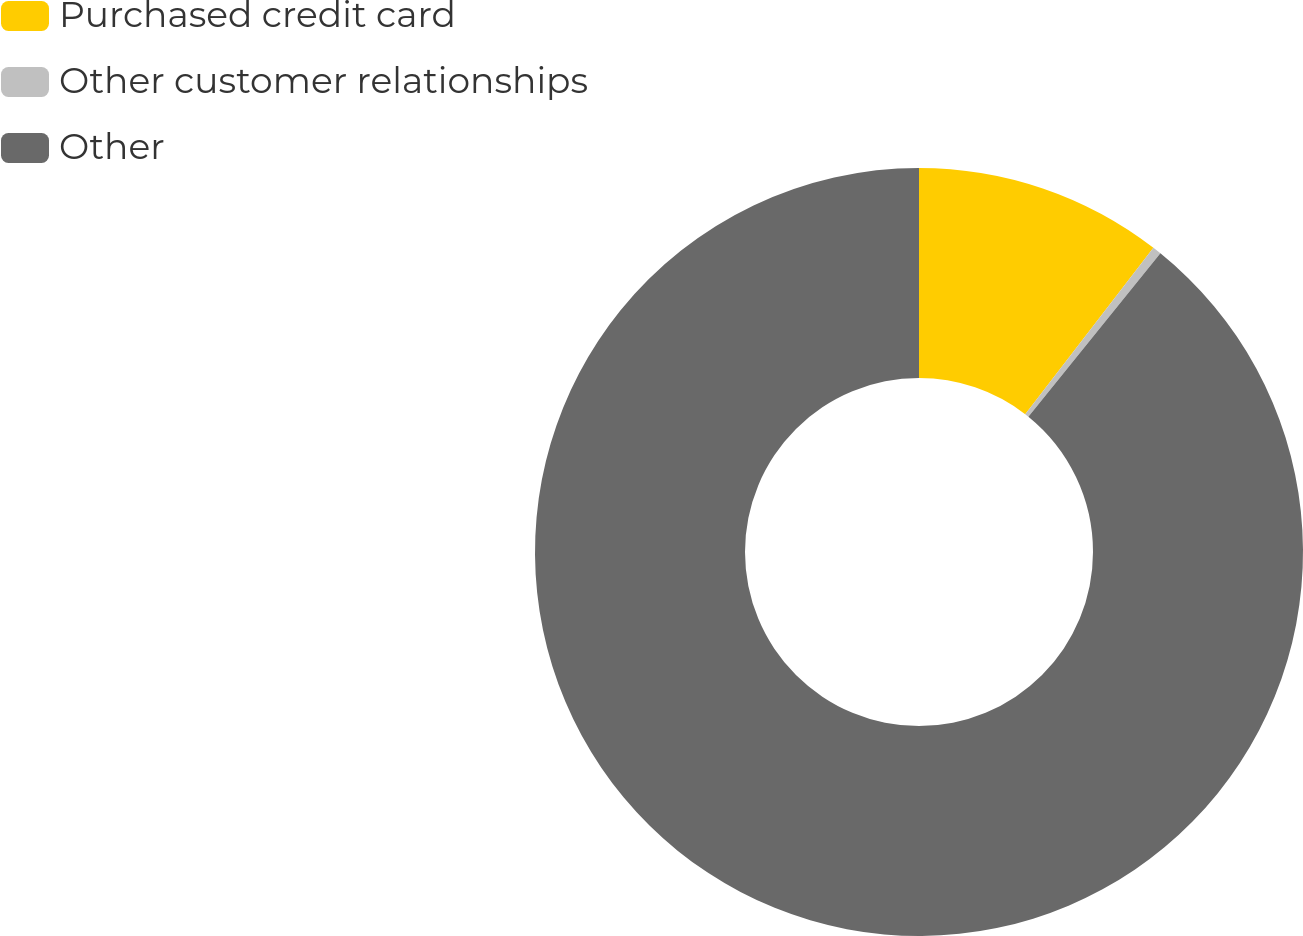<chart> <loc_0><loc_0><loc_500><loc_500><pie_chart><fcel>Purchased credit card<fcel>Other customer relationships<fcel>Other<nl><fcel>10.45%<fcel>0.37%<fcel>89.18%<nl></chart> 